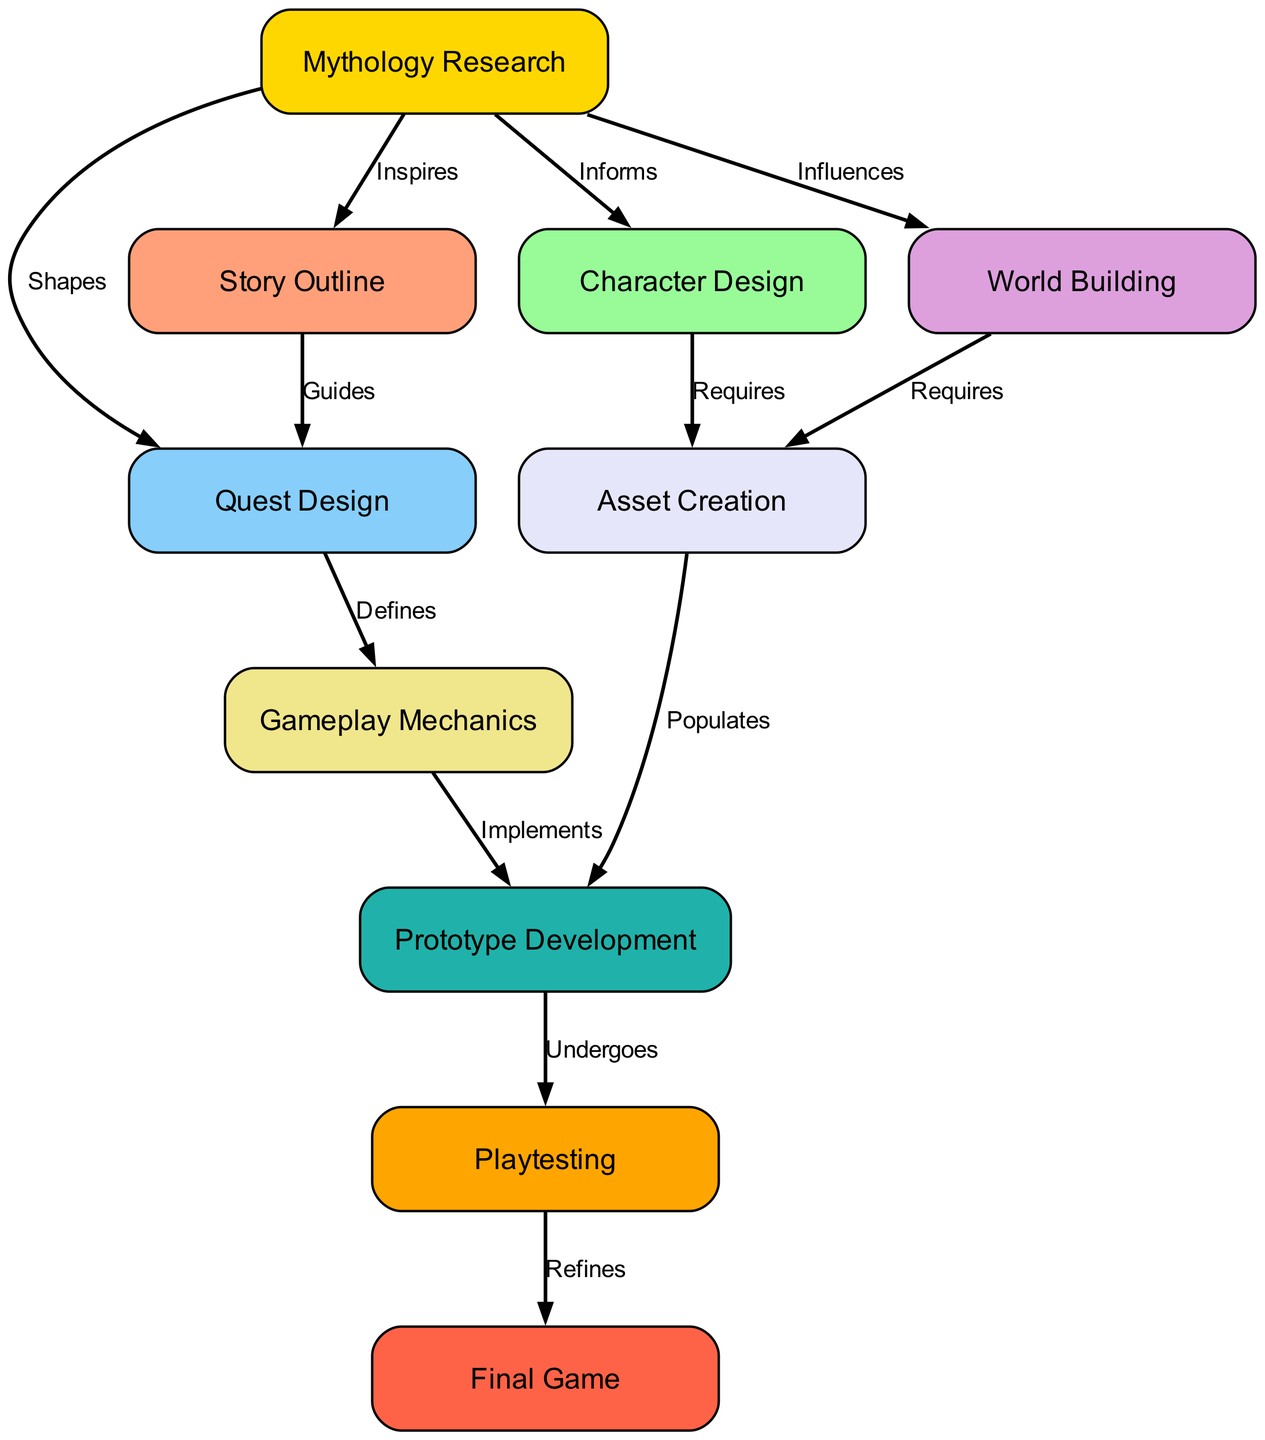What is the first step in the game development workflow? The first step is marked as "Mythology Research" in the diagram, indicating that this is the initial phase where themes and sources are explored.
Answer: Mythology Research How many total nodes are represented in the diagram? By counting all the distinct boxes or nodes shown in the diagram, there are a total of ten nodes listed.
Answer: 10 What relationship does "Mythology Research" have with "Story Outline"? The edge between "Mythology Research" and "Story Outline" is labeled "Inspires," showing that the research directly influences the creation of the story outline.
Answer: Inspires Which node comes directly after "Prototype Development" in the workflow? The diagram shows that the flow proceeds from "Prototype Development" to "Playtesting," indicating that testing follows the development of the prototype.
Answer: Playtesting How many edges are there connecting the nodes in the diagram? By examining the connections depicted in the diagram, it can be determined that there are a total of twelve edges linking the various nodes together.
Answer: 12 What does the edge between "Quest Design" and "Gameplay Mechanics" signify? The edge labeled "Defines" indicates that "Quest Design" plays a crucial role in shaping and determining the "Gameplay Mechanics" of the game.
Answer: Defines What color is generally used for the node representing "World Building"? Upon inspecting the diagram, the node "World Building" is represented in a light purple shade corresponding to the custom color palette assigned in the diagram.
Answer: Light Purple Which node requires assets according to the diagram? The diagram depicts that both "Character Design" and "World Building" have edges labeled "Requires," indicating that they both necessitate asset creation.
Answer: Character Design, World Building What is the last step or output of the workflow? The final output, as shown in the diagram, is labeled "Final Game," which illustrates the completion of the entire development process.
Answer: Final Game 